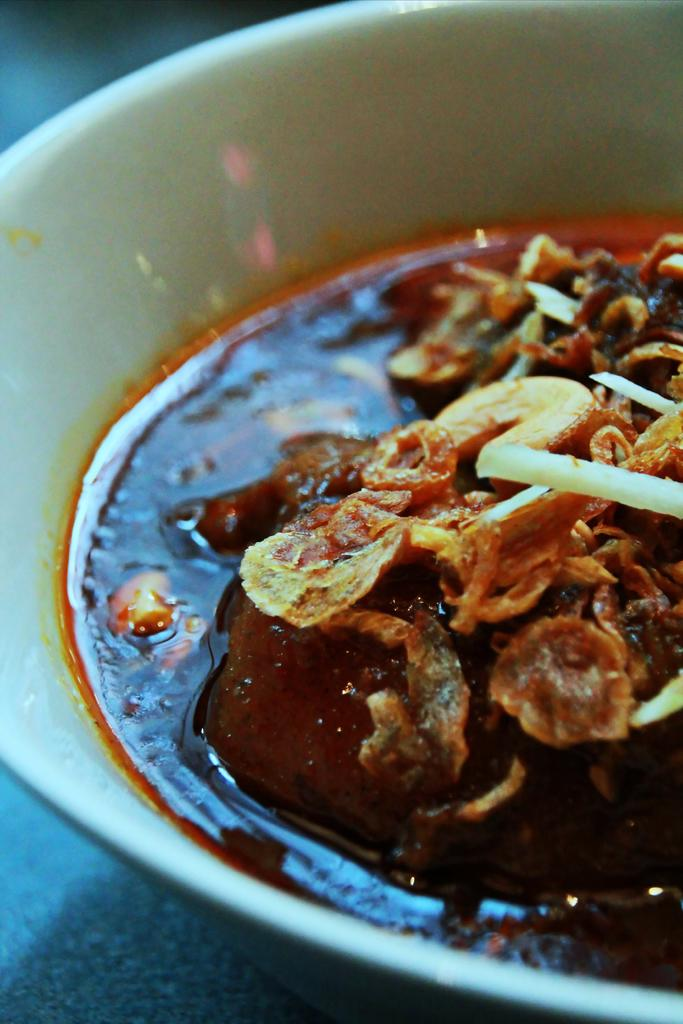What is present in the bowl that is visible in the image? The bowl is filled with a food item. Where is the bowl located in the image? The bowl is present on a table. What can be inferred about the food item in the bowl based on the image? The food item appears to be a solid, as it is contained within the bowl. Can you see the sun shining on the bowl in the image? The image does not show the sun or any indication of sunlight, so it cannot be determined if the sun is shining on the bowl. 